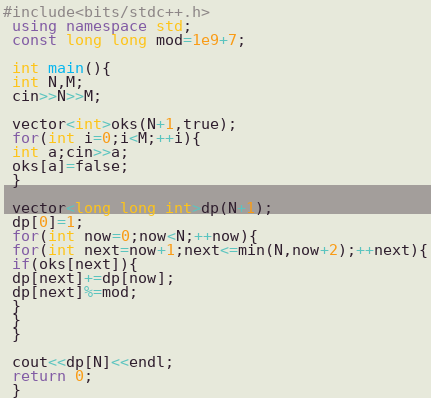<code> <loc_0><loc_0><loc_500><loc_500><_C++_>#include<bits/stdc++.h>
 using namespace std;
 const long long mod=1e9+7;

 int main(){
 int N,M;
 cin>>N>>M;

 vector<int>oks(N+1,true);
 for(int i=0;i<M;++i){
 int a;cin>>a;
 oks[a]=false;
 }

 vector<long long int>dp(N+1);
 dp[0]=1;
 for(int now=0;now<N;++now){
 for(int next=now+1;next<=min(N,now+2);++next){
 if(oks[next]){
 dp[next]+=dp[now];
 dp[next]%=mod;
 }
 }
 }

 cout<<dp[N]<<endl;
 return 0;
 }
</code> 